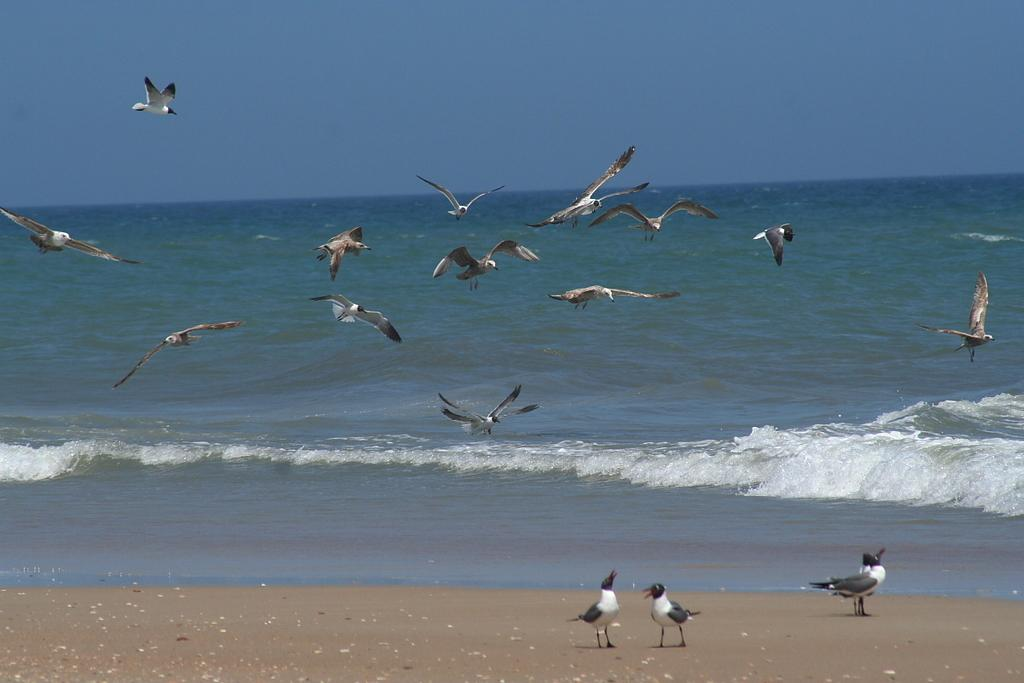What type of animals are present in the image? There are birds flying and standing in the image. Can you describe the birds' actions in the image? Some birds are flying, while others are standing. What can be seen in the background of the image? There is an ocean visible in the background of the image. What type of soup is being served at the event in the image? There is no event or soup present in the image; it features birds flying and standing with an ocean in the background. 